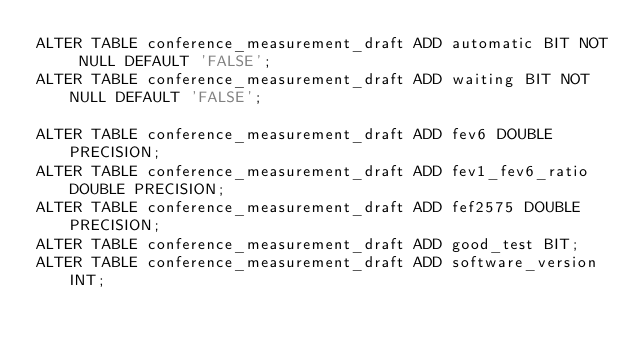<code> <loc_0><loc_0><loc_500><loc_500><_SQL_>ALTER TABLE conference_measurement_draft ADD automatic BIT NOT NULL DEFAULT 'FALSE';
ALTER TABLE conference_measurement_draft ADD waiting BIT NOT NULL DEFAULT 'FALSE';

ALTER TABLE conference_measurement_draft ADD fev6 DOUBLE PRECISION;
ALTER TABLE conference_measurement_draft ADD fev1_fev6_ratio DOUBLE PRECISION;
ALTER TABLE conference_measurement_draft ADD fef2575 DOUBLE PRECISION;
ALTER TABLE conference_measurement_draft ADD good_test BIT;
ALTER TABLE conference_measurement_draft ADD software_version INT;
</code> 